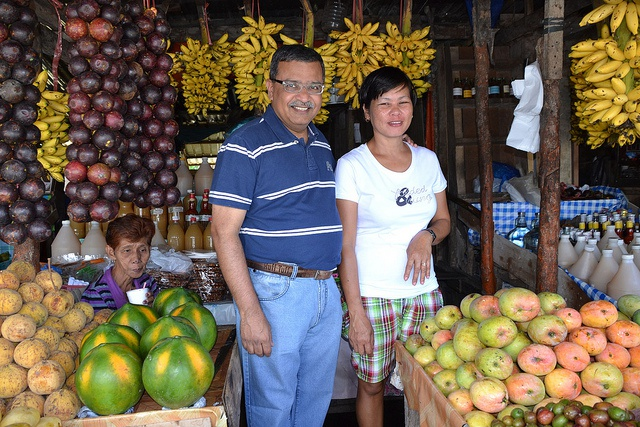Describe the objects in this image and their specific colors. I can see people in black, blue, gray, and lightblue tones, people in black, white, gray, and darkgray tones, banana in black, olive, and orange tones, bottle in black, gray, darkgray, and maroon tones, and people in black, gray, and maroon tones in this image. 